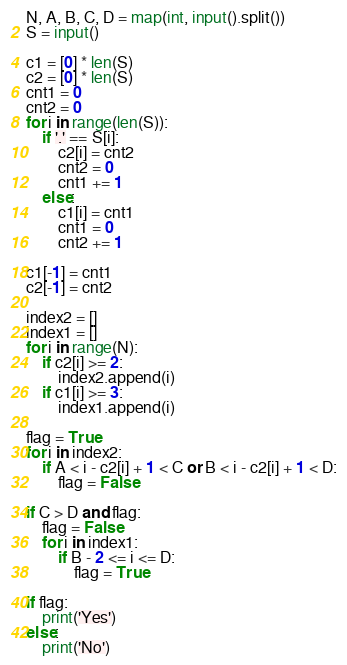<code> <loc_0><loc_0><loc_500><loc_500><_Python_>N, A, B, C, D = map(int, input().split())
S = input()

c1 = [0] * len(S)
c2 = [0] * len(S)
cnt1 = 0
cnt2 = 0
for i in range(len(S)):
    if '.' == S[i]:
        c2[i] = cnt2
        cnt2 = 0
        cnt1 += 1
    else:
        c1[i] = cnt1
        cnt1 = 0
        cnt2 += 1

c1[-1] = cnt1
c2[-1] = cnt2

index2 = []
index1 = []
for i in range(N):
    if c2[i] >= 2:
        index2.append(i)
    if c1[i] >= 3:
        index1.append(i)

flag = True
for i in index2:
    if A < i - c2[i] + 1 < C or B < i - c2[i] + 1 < D:
        flag = False

if C > D and flag:
    flag = False
    for i in index1:
        if B - 2 <= i <= D:
            flag = True

if flag:
    print('Yes')
else:
    print('No')
</code> 